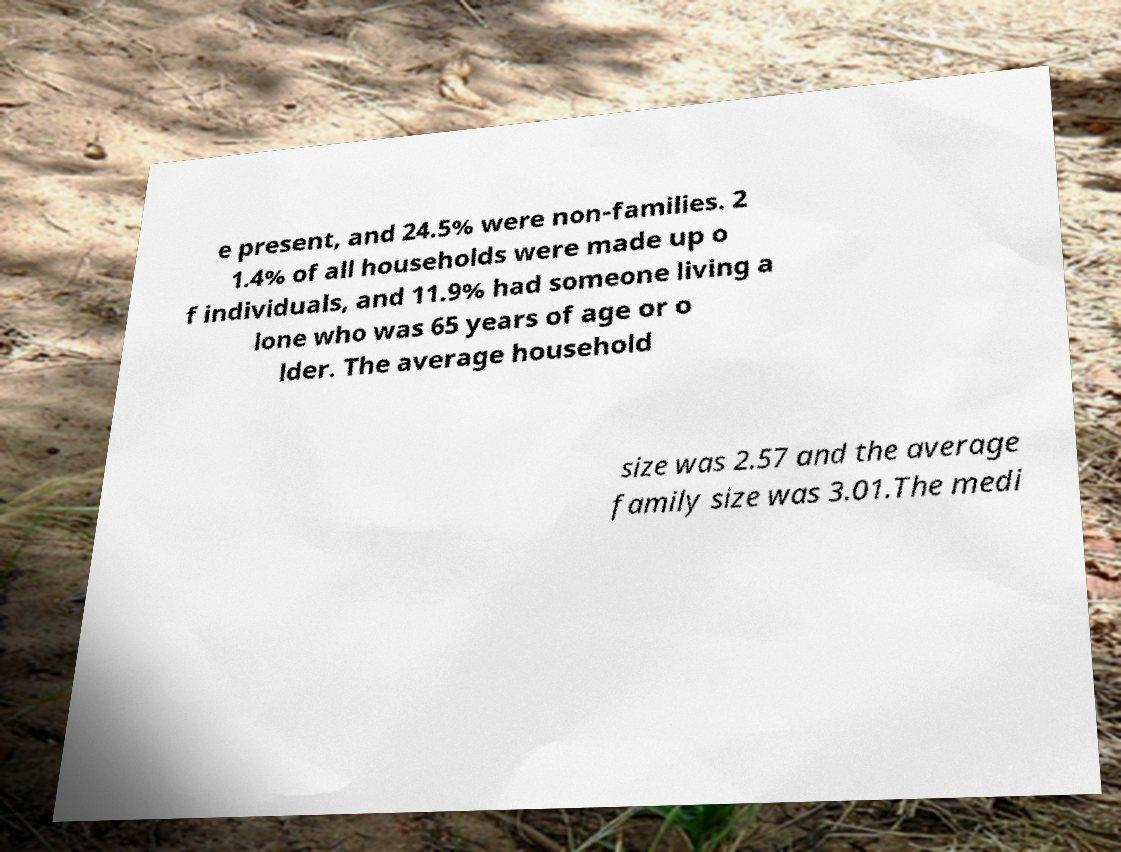For documentation purposes, I need the text within this image transcribed. Could you provide that? e present, and 24.5% were non-families. 2 1.4% of all households were made up o f individuals, and 11.9% had someone living a lone who was 65 years of age or o lder. The average household size was 2.57 and the average family size was 3.01.The medi 